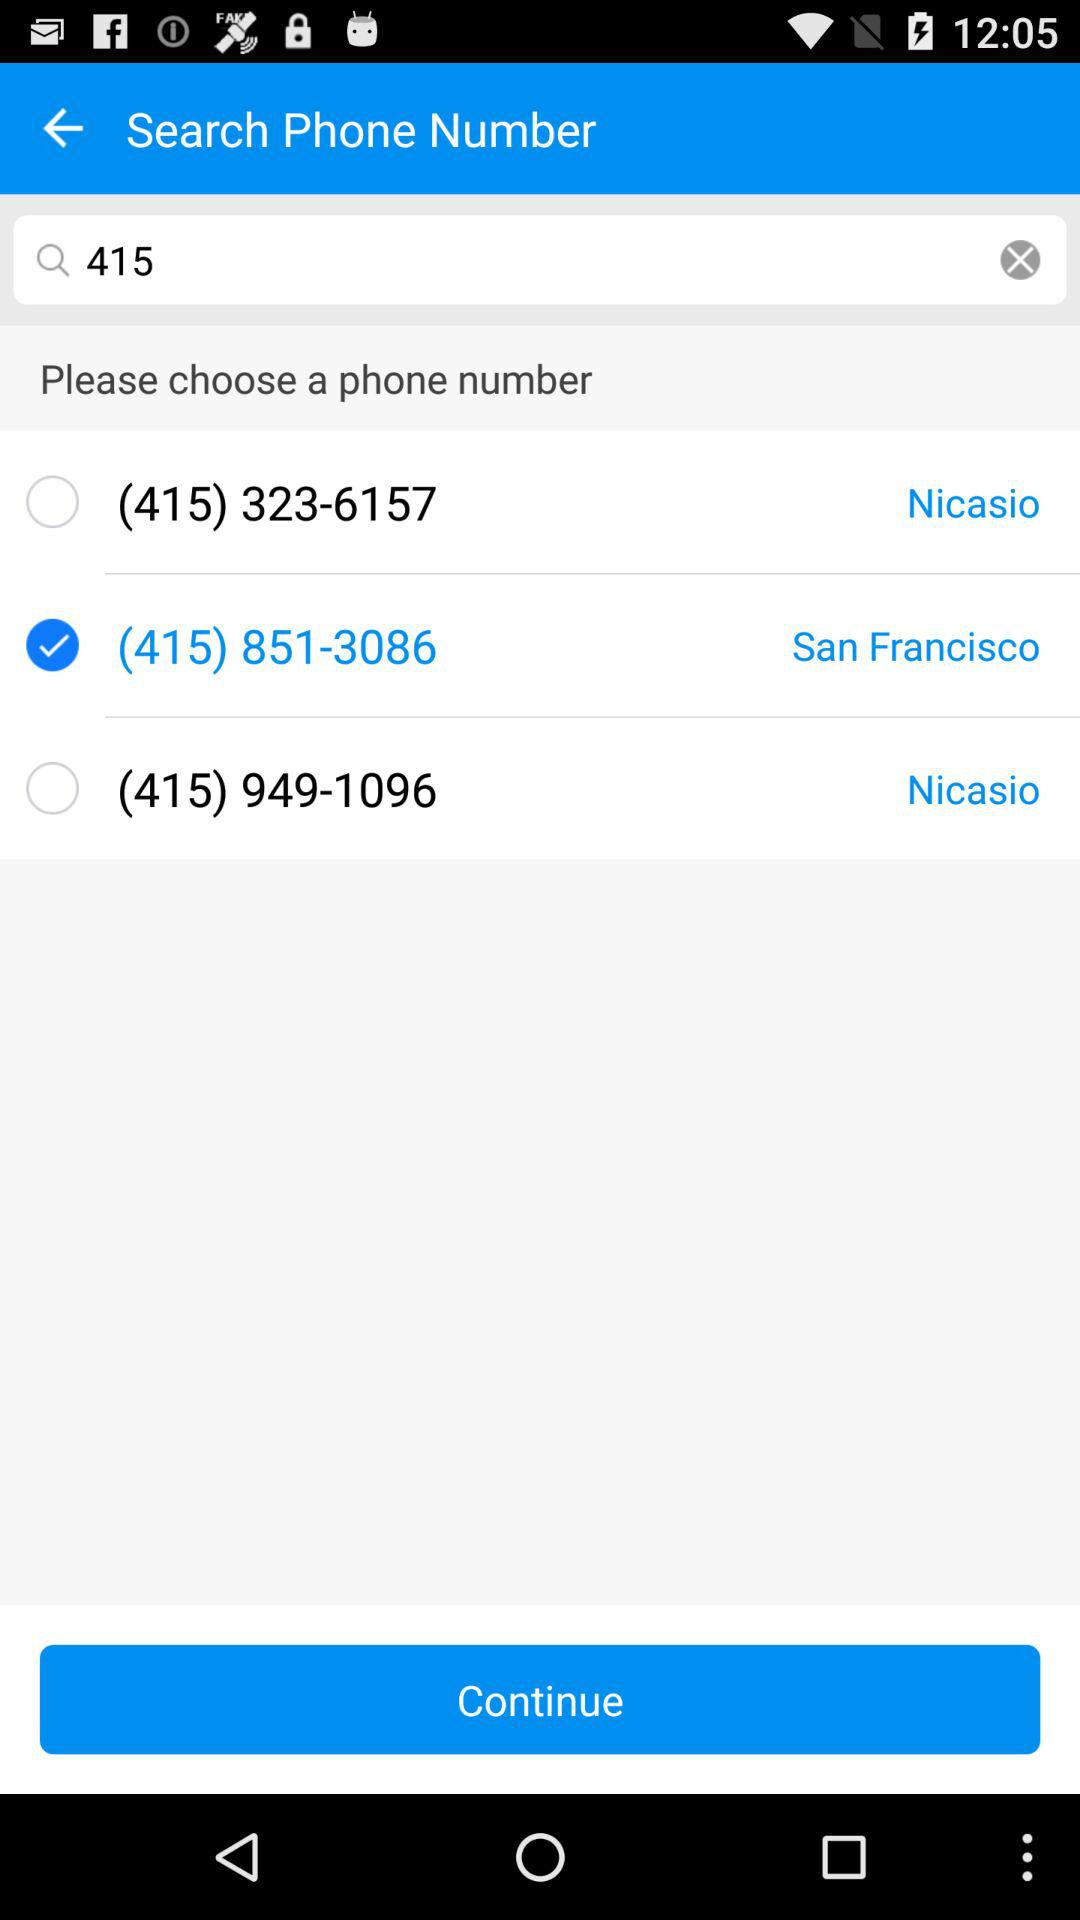Which phone number is selected? The selected phone number is (415) 851-3086. 